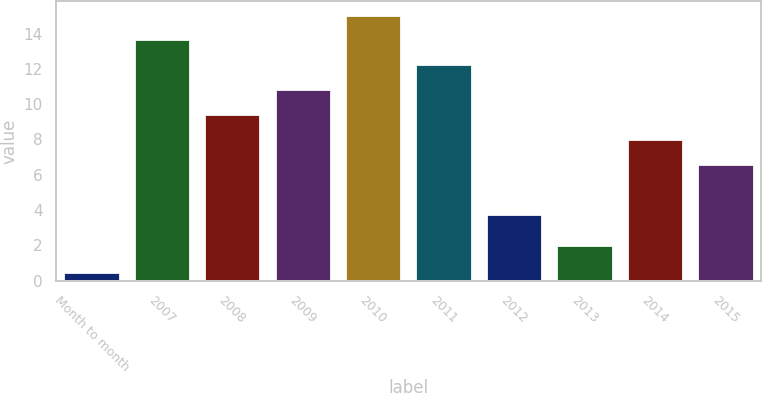Convert chart to OTSL. <chart><loc_0><loc_0><loc_500><loc_500><bar_chart><fcel>Month to month<fcel>2007<fcel>2008<fcel>2009<fcel>2010<fcel>2011<fcel>2012<fcel>2013<fcel>2014<fcel>2015<nl><fcel>0.5<fcel>13.67<fcel>9.44<fcel>10.85<fcel>15.08<fcel>12.26<fcel>3.8<fcel>2<fcel>8.03<fcel>6.62<nl></chart> 